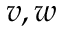Convert formula to latex. <formula><loc_0><loc_0><loc_500><loc_500>v , w</formula> 